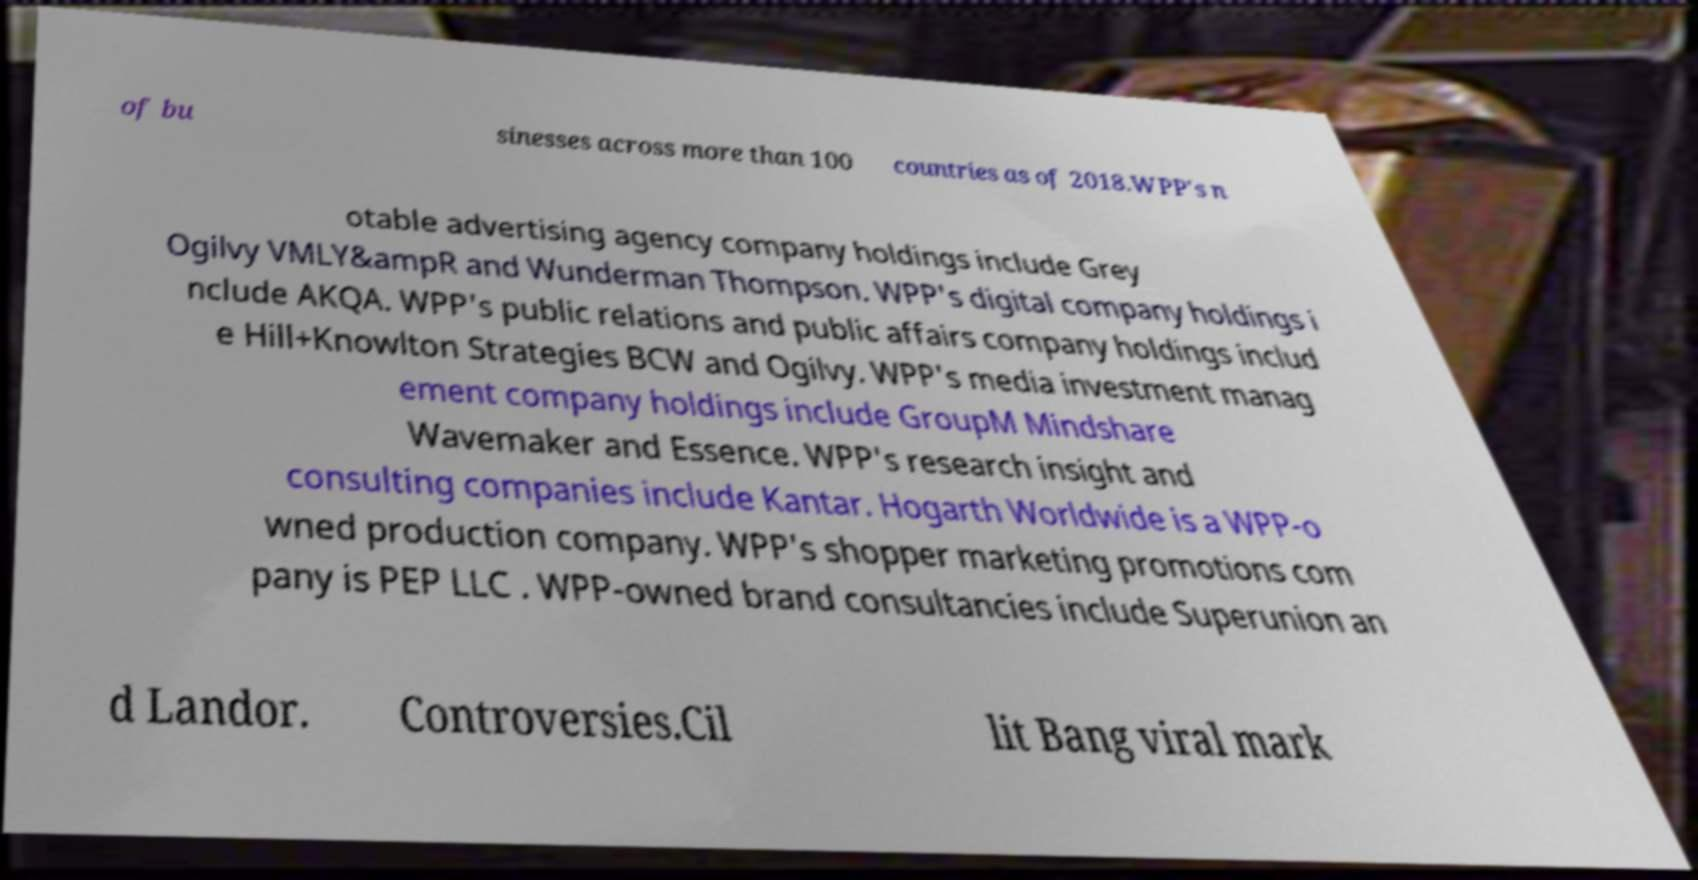For documentation purposes, I need the text within this image transcribed. Could you provide that? of bu sinesses across more than 100 countries as of 2018.WPP's n otable advertising agency company holdings include Grey Ogilvy VMLY&ampR and Wunderman Thompson. WPP's digital company holdings i nclude AKQA. WPP's public relations and public affairs company holdings includ e Hill+Knowlton Strategies BCW and Ogilvy. WPP's media investment manag ement company holdings include GroupM Mindshare Wavemaker and Essence. WPP's research insight and consulting companies include Kantar. Hogarth Worldwide is a WPP-o wned production company. WPP's shopper marketing promotions com pany is PEP LLC . WPP-owned brand consultancies include Superunion an d Landor. Controversies.Cil lit Bang viral mark 